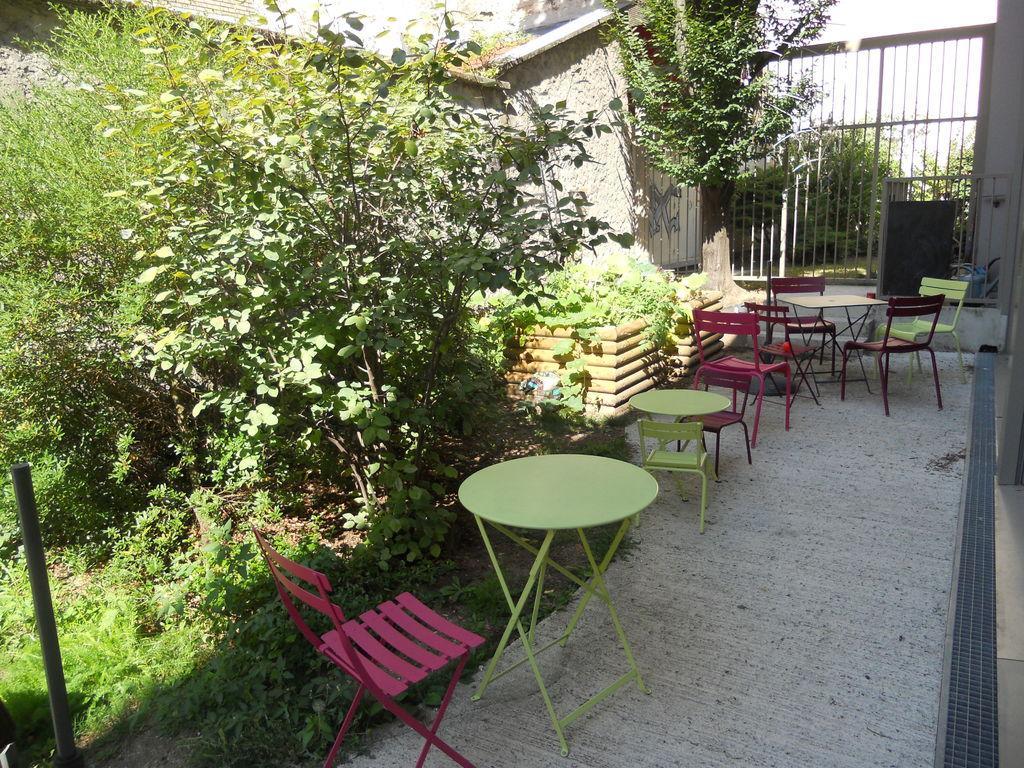In one or two sentences, can you explain what this image depicts? In this image there are benches around the benches there are chairs and there are trees, in the background there is a gate. 